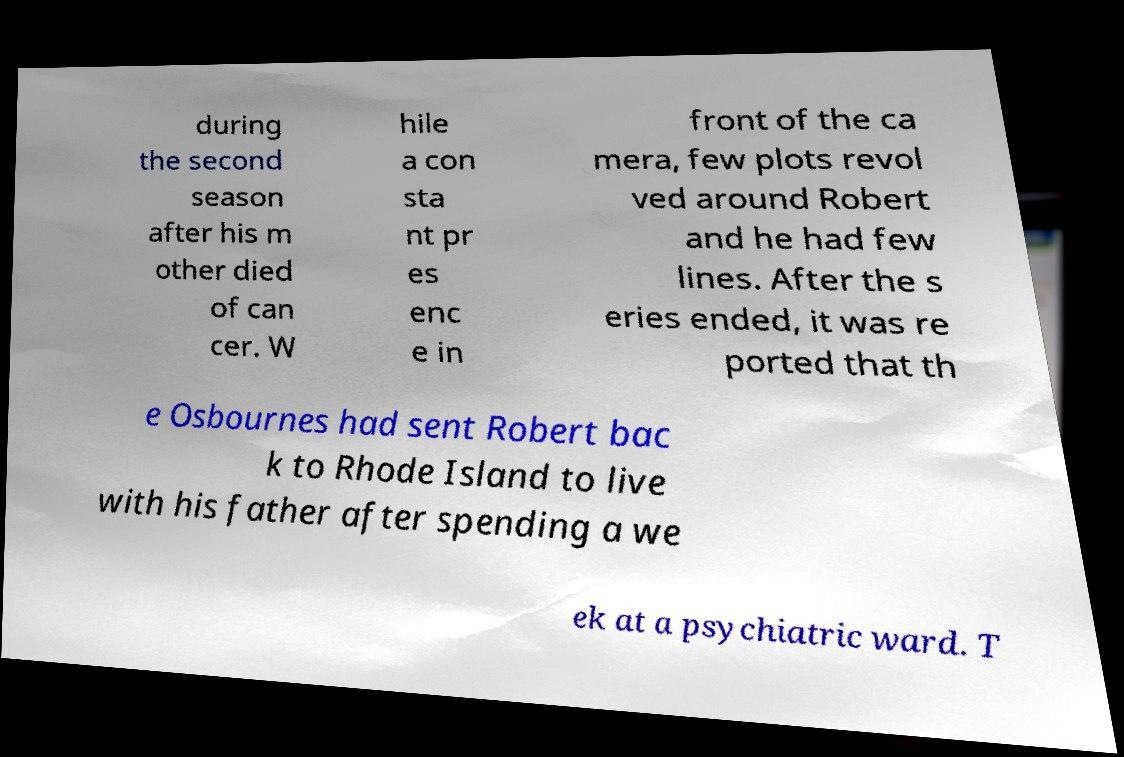Can you read and provide the text displayed in the image?This photo seems to have some interesting text. Can you extract and type it out for me? during the second season after his m other died of can cer. W hile a con sta nt pr es enc e in front of the ca mera, few plots revol ved around Robert and he had few lines. After the s eries ended, it was re ported that th e Osbournes had sent Robert bac k to Rhode Island to live with his father after spending a we ek at a psychiatric ward. T 